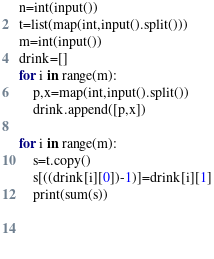Convert code to text. <code><loc_0><loc_0><loc_500><loc_500><_Python_>n=int(input())
t=list(map(int,input().split()))
m=int(input())
drink=[]
for i in range(m):
    p,x=map(int,input().split())
    drink.append([p,x])

for i in range(m):
    s=t.copy()
    s[((drink[i][0])-1)]=drink[i][1]
    print(sum(s))
    
    
    
</code> 